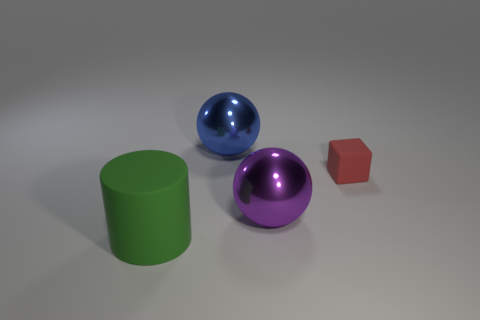There is another metal object that is the same shape as the big purple thing; what is its size? The other metal object, which is a blue sphere, appears to be slightly smaller than the big purple sphere. While the exact dimensions aren't provided, we can estimate that it is of a medium size relative to the items pictured. 